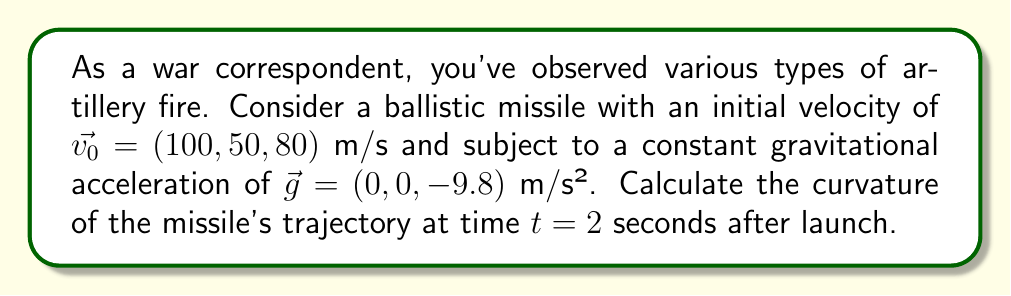What is the answer to this math problem? To calculate the curvature of the ballistic trajectory in 3D space, we'll follow these steps:

1) The position vector $\vec{r}(t)$ of the missile at time $t$ is given by:
   $$\vec{r}(t) = \vec{r_0} + \vec{v_0}t + \frac{1}{2}\vec{g}t^2$$
   where $\vec{r_0}$ is the initial position (which we can assume to be the origin).

2) The velocity vector $\vec{v}(t)$ is the first derivative of $\vec{r}(t)$:
   $$\vec{v}(t) = \vec{v_0} + \vec{g}t = (100, 50, 80-9.8t)$$

3) The acceleration vector $\vec{a}(t)$ is the second derivative of $\vec{r}(t)$:
   $$\vec{a}(t) = \vec{g} = (0, 0, -9.8)$$

4) The curvature $\kappa$ at any point on the trajectory is given by:
   $$\kappa = \frac{|\vec{v} \times \vec{a}|}{|\vec{v}|^3}$$

5) At $t = 2$ seconds:
   $\vec{v}(2) = (100, 50, 60.4)$
   $\vec{a}(2) = (0, 0, -9.8)$

6) Calculate $\vec{v} \times \vec{a}$:
   $$\vec{v} \times \vec{a} = \begin{vmatrix} 
   \hat{i} & \hat{j} & \hat{k} \\
   100 & 50 & 60.4 \\
   0 & 0 & -9.8
   \end{vmatrix} = (-490, 980, 0)$$

7) Calculate $|\vec{v} \times \vec{a}|$:
   $$|\vec{v} \times \vec{a}| = \sqrt{(-490)^2 + 980^2 + 0^2} = 1095.45$$

8) Calculate $|\vec{v}|$:
   $$|\vec{v}| = \sqrt{100^2 + 50^2 + 60.4^2} = 127.59$$

9) Finally, calculate the curvature:
   $$\kappa = \frac{1095.45}{127.59^3} = 0.00527 \text{ m}^{-1}$$
Answer: $0.00527 \text{ m}^{-1}$ 